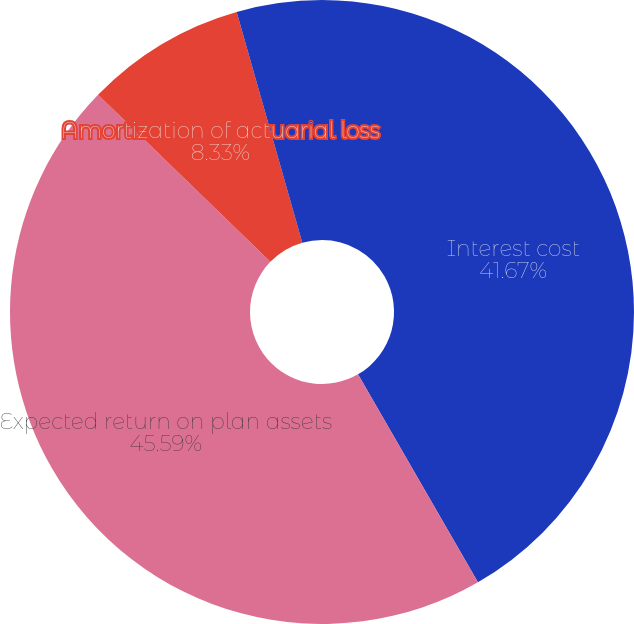Convert chart to OTSL. <chart><loc_0><loc_0><loc_500><loc_500><pie_chart><fcel>Interest cost<fcel>Expected return on plan assets<fcel>Amortization of actuarial loss<fcel>Net periodic benefit cost<nl><fcel>41.67%<fcel>45.59%<fcel>8.33%<fcel>4.41%<nl></chart> 